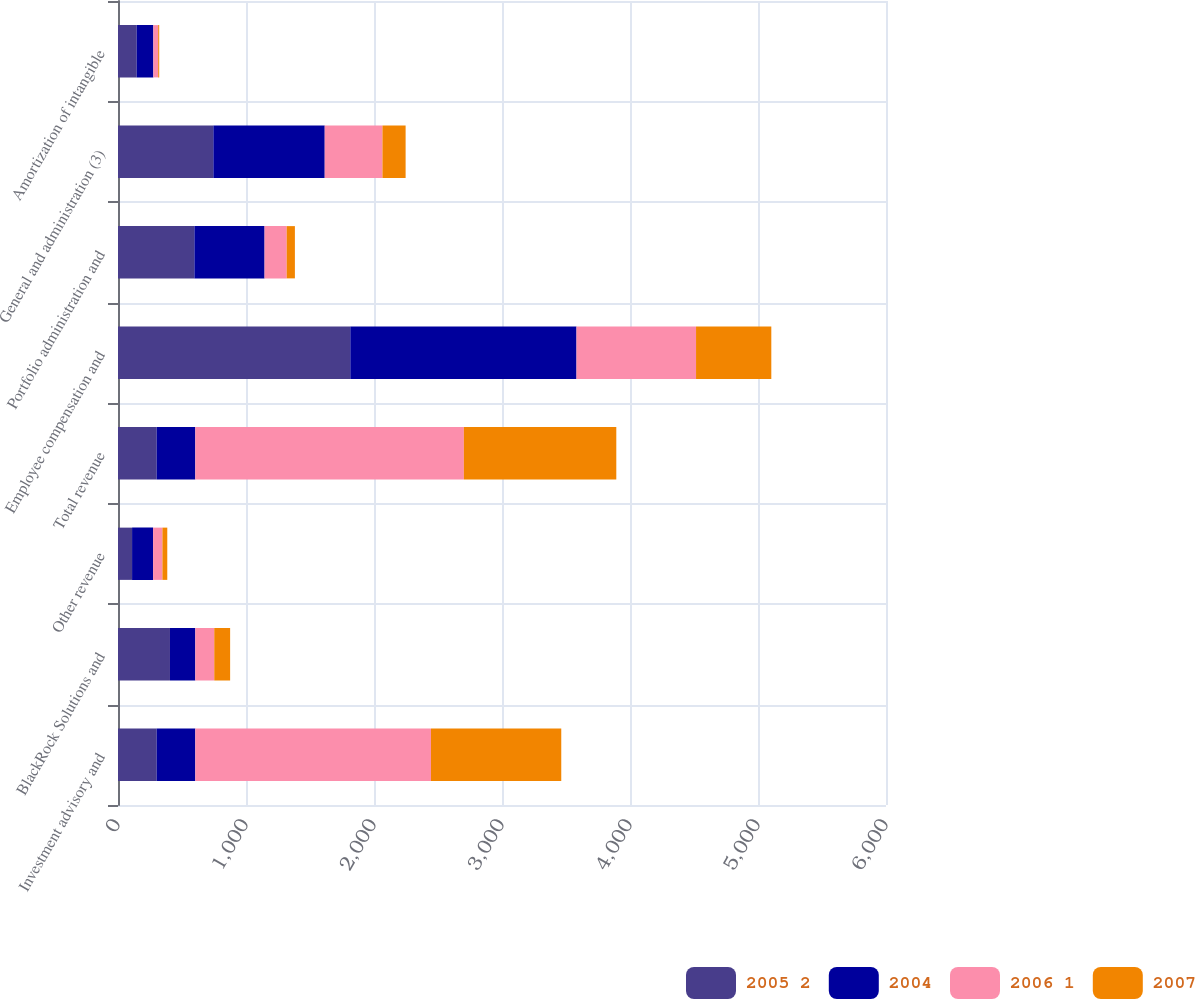Convert chart. <chart><loc_0><loc_0><loc_500><loc_500><stacked_bar_chart><ecel><fcel>Investment advisory and<fcel>BlackRock Solutions and<fcel>Other revenue<fcel>Total revenue<fcel>Employee compensation and<fcel>Portfolio administration and<fcel>General and administration (3)<fcel>Amortization of intangible<nl><fcel>2005 2<fcel>302<fcel>406<fcel>110<fcel>302<fcel>1815<fcel>597<fcel>745<fcel>146<nl><fcel>2004<fcel>302<fcel>198<fcel>164<fcel>302<fcel>1767<fcel>548<fcel>870<fcel>130<nl><fcel>2006 1<fcel>1841<fcel>148<fcel>73<fcel>2098<fcel>934<fcel>173<fcel>451<fcel>38<nl><fcel>2007<fcel>1018<fcel>124<fcel>38<fcel>1191<fcel>588<fcel>64<fcel>181<fcel>8<nl></chart> 